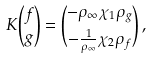Convert formula to latex. <formula><loc_0><loc_0><loc_500><loc_500>K \binom { f } { g } = \binom { - \rho _ { \infty } \chi _ { 1 } \rho _ { g } } { - \frac { 1 } { \rho _ { \infty } } \chi _ { 2 } \rho _ { f } } \, ,</formula> 